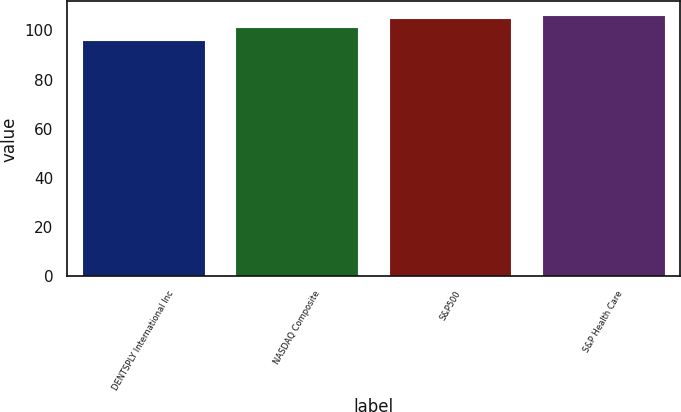Convert chart to OTSL. <chart><loc_0><loc_0><loc_500><loc_500><bar_chart><fcel>DENTSPLY International Inc<fcel>NASDAQ Composite<fcel>S&P500<fcel>S&P Health Care<nl><fcel>95.97<fcel>101.33<fcel>104.91<fcel>106.46<nl></chart> 